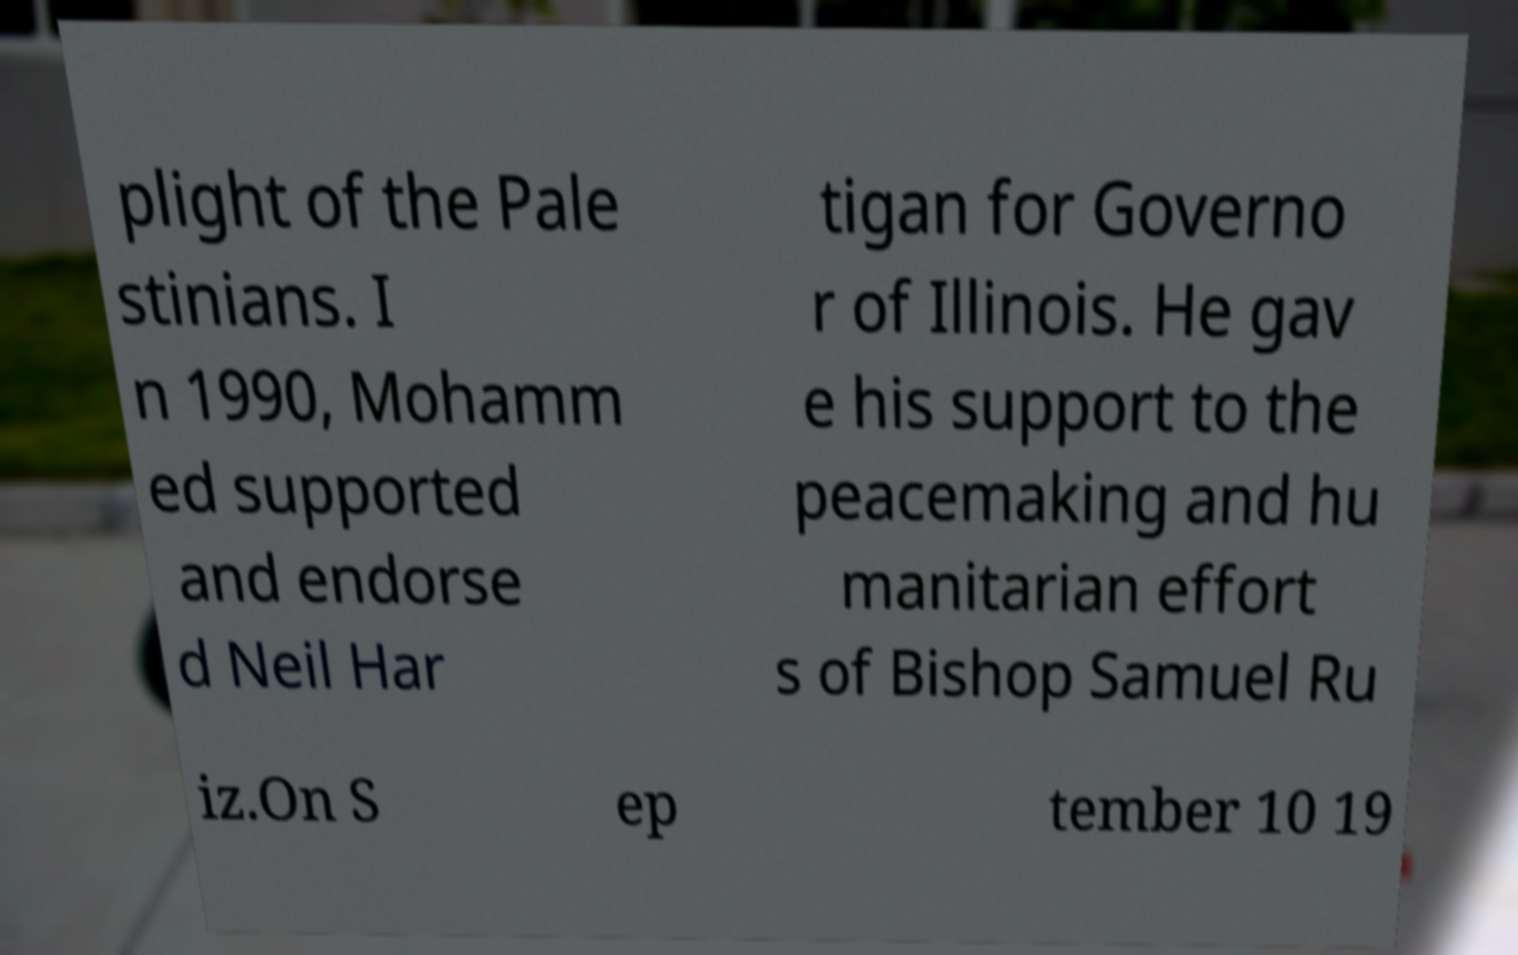Could you assist in decoding the text presented in this image and type it out clearly? plight of the Pale stinians. I n 1990, Mohamm ed supported and endorse d Neil Har tigan for Governo r of Illinois. He gav e his support to the peacemaking and hu manitarian effort s of Bishop Samuel Ru iz.On S ep tember 10 19 